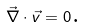<formula> <loc_0><loc_0><loc_500><loc_500>\vec { \nabla } \cdot \vec { v } = 0 \text {.}</formula> 